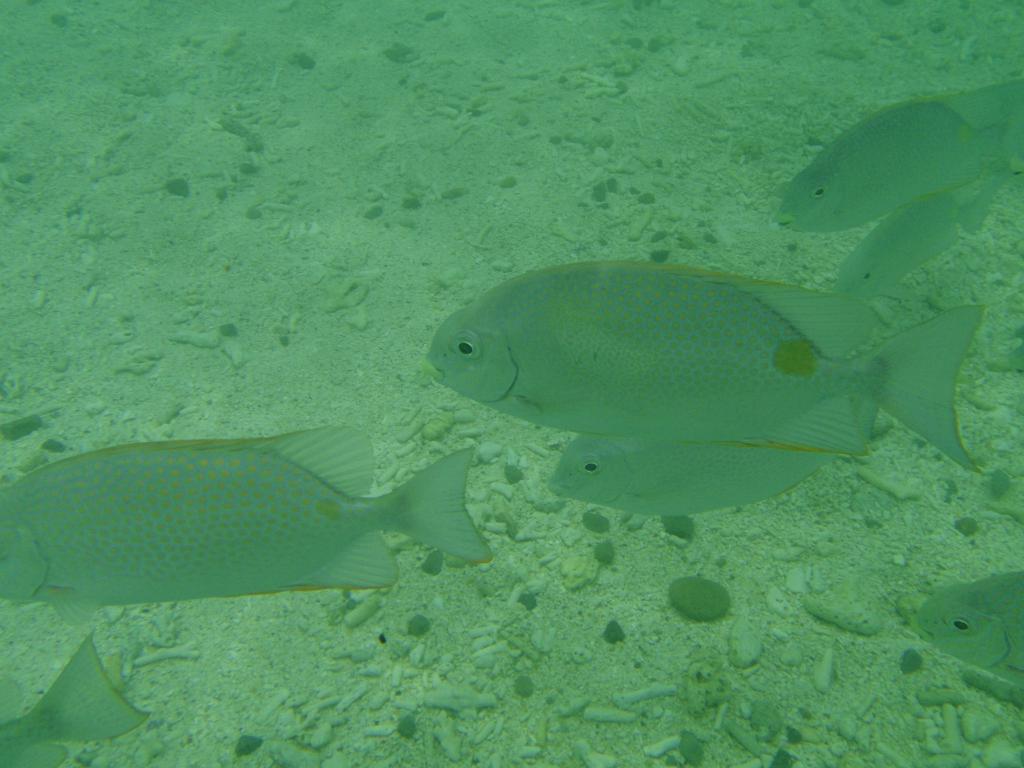Describe this image in one or two sentences. In this image I can see few fishes in the water which are green in color. I can see the ground and few small rocks on the ground. 